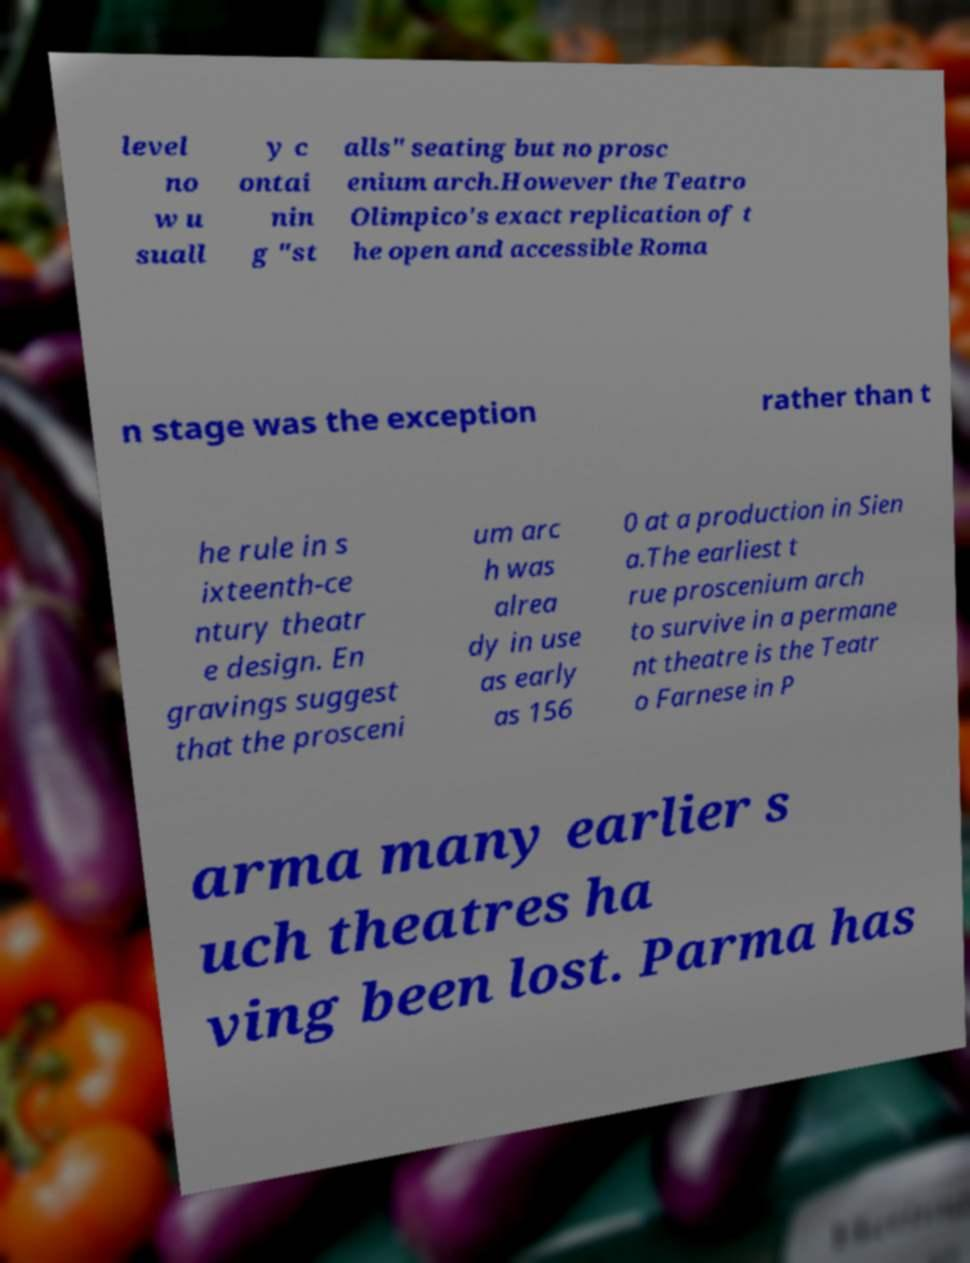Can you accurately transcribe the text from the provided image for me? level no w u suall y c ontai nin g "st alls" seating but no prosc enium arch.However the Teatro Olimpico's exact replication of t he open and accessible Roma n stage was the exception rather than t he rule in s ixteenth-ce ntury theatr e design. En gravings suggest that the prosceni um arc h was alrea dy in use as early as 156 0 at a production in Sien a.The earliest t rue proscenium arch to survive in a permane nt theatre is the Teatr o Farnese in P arma many earlier s uch theatres ha ving been lost. Parma has 